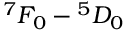<formula> <loc_0><loc_0><loc_500><loc_500>^ { 7 } F _ { 0 } ^ { 5 } D _ { 0 }</formula> 